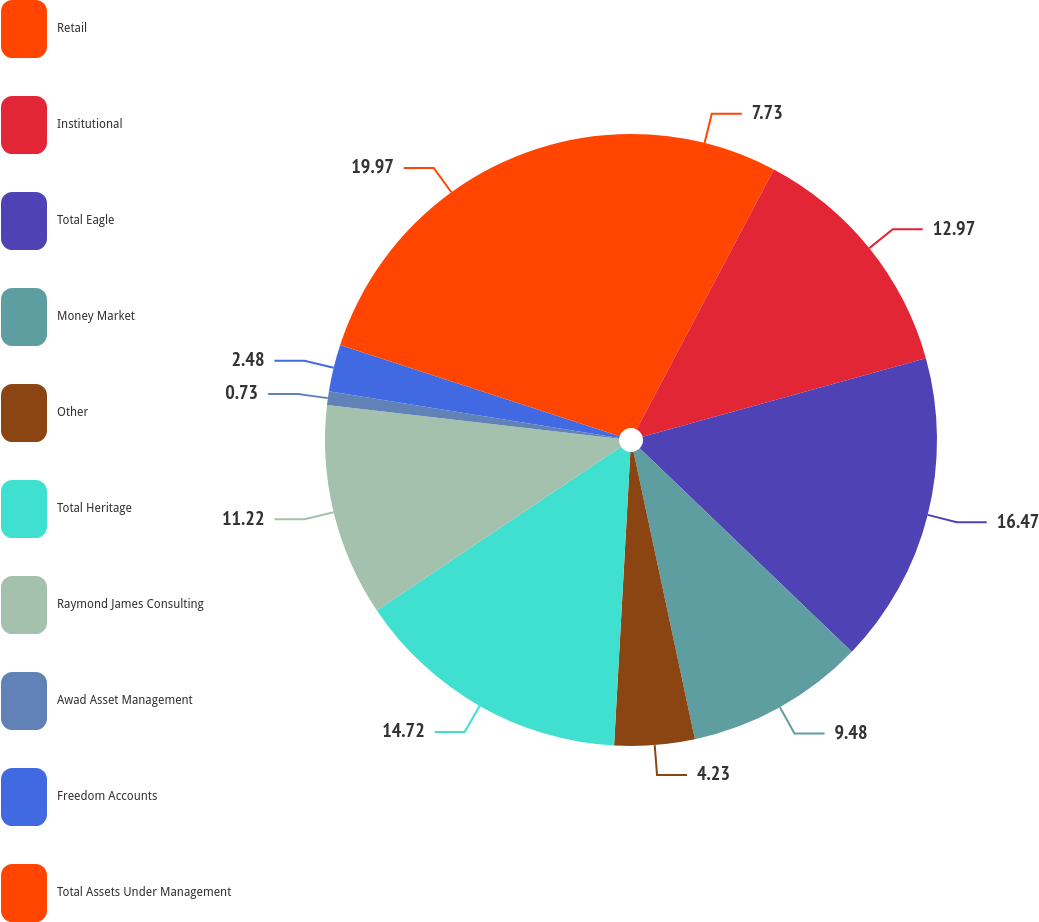<chart> <loc_0><loc_0><loc_500><loc_500><pie_chart><fcel>Retail<fcel>Institutional<fcel>Total Eagle<fcel>Money Market<fcel>Other<fcel>Total Heritage<fcel>Raymond James Consulting<fcel>Awad Asset Management<fcel>Freedom Accounts<fcel>Total Assets Under Management<nl><fcel>7.73%<fcel>12.97%<fcel>16.47%<fcel>9.48%<fcel>4.23%<fcel>14.72%<fcel>11.22%<fcel>0.73%<fcel>2.48%<fcel>19.97%<nl></chart> 